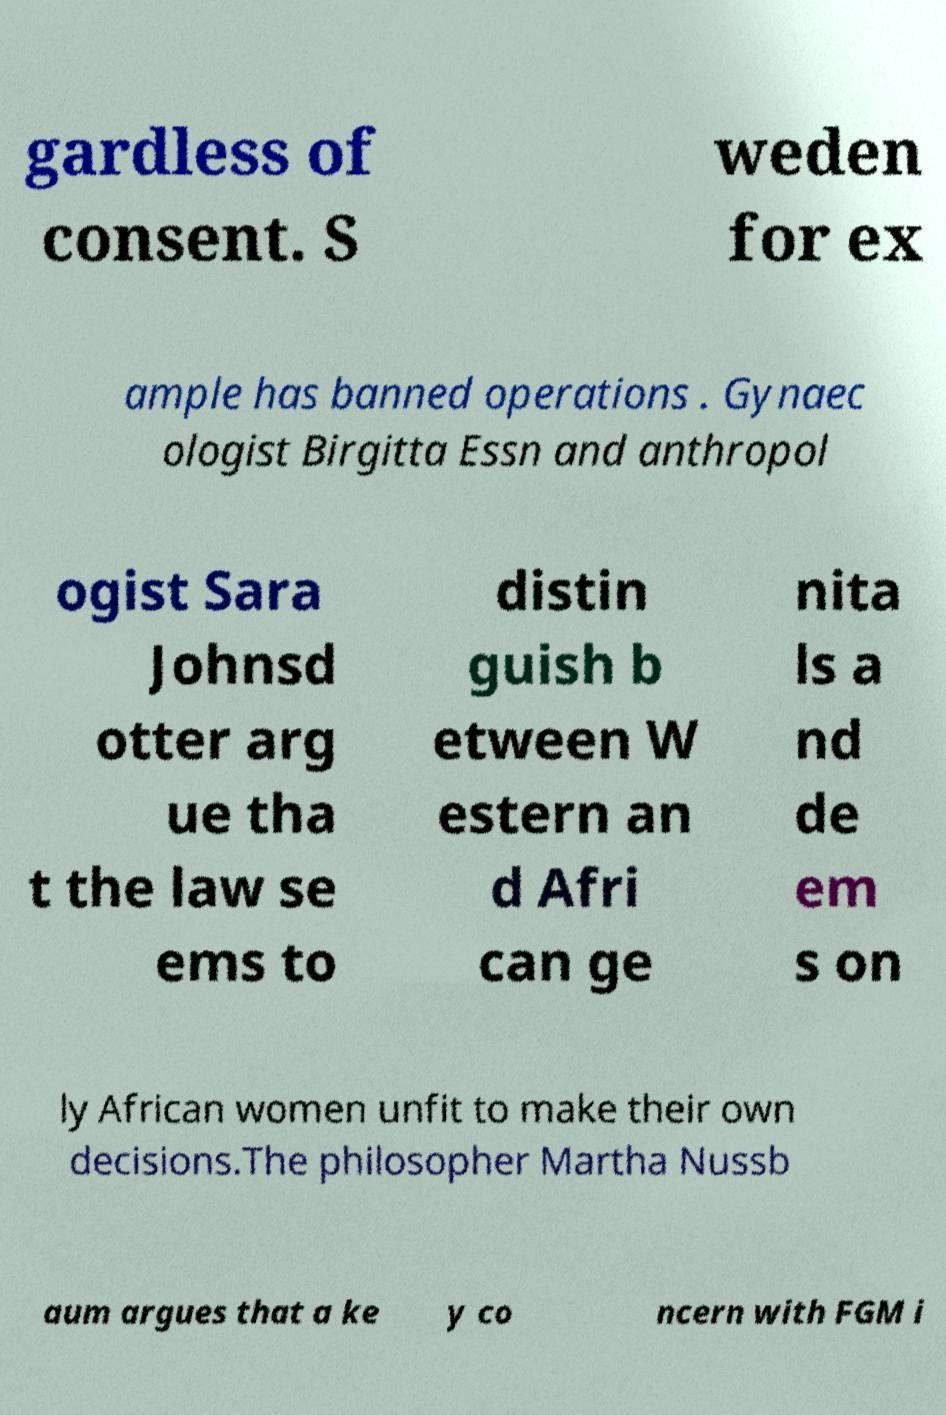For documentation purposes, I need the text within this image transcribed. Could you provide that? gardless of consent. S weden for ex ample has banned operations . Gynaec ologist Birgitta Essn and anthropol ogist Sara Johnsd otter arg ue tha t the law se ems to distin guish b etween W estern an d Afri can ge nita ls a nd de em s on ly African women unfit to make their own decisions.The philosopher Martha Nussb aum argues that a ke y co ncern with FGM i 